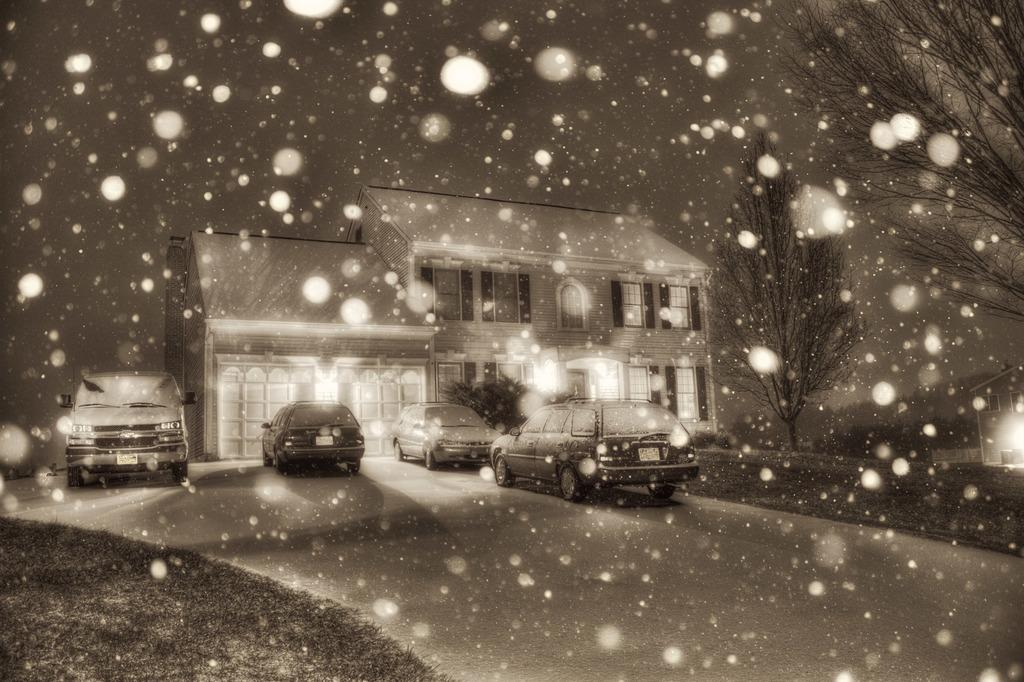What type of structure is visible in the image? There is a building in the image. How many cars can be seen in the image? There are four cars in the image. What type of vegetation is present at the bottom of the image? Grass is present at the bottom of the image. What type of surface is visible at the bottom of the image? There is a road at the bottom of the image. What type of balloon can be seen floating above the building in the image? There is no balloon present in the image. What type of toys are scattered on the grass in the image? There are no toys present in the image. 